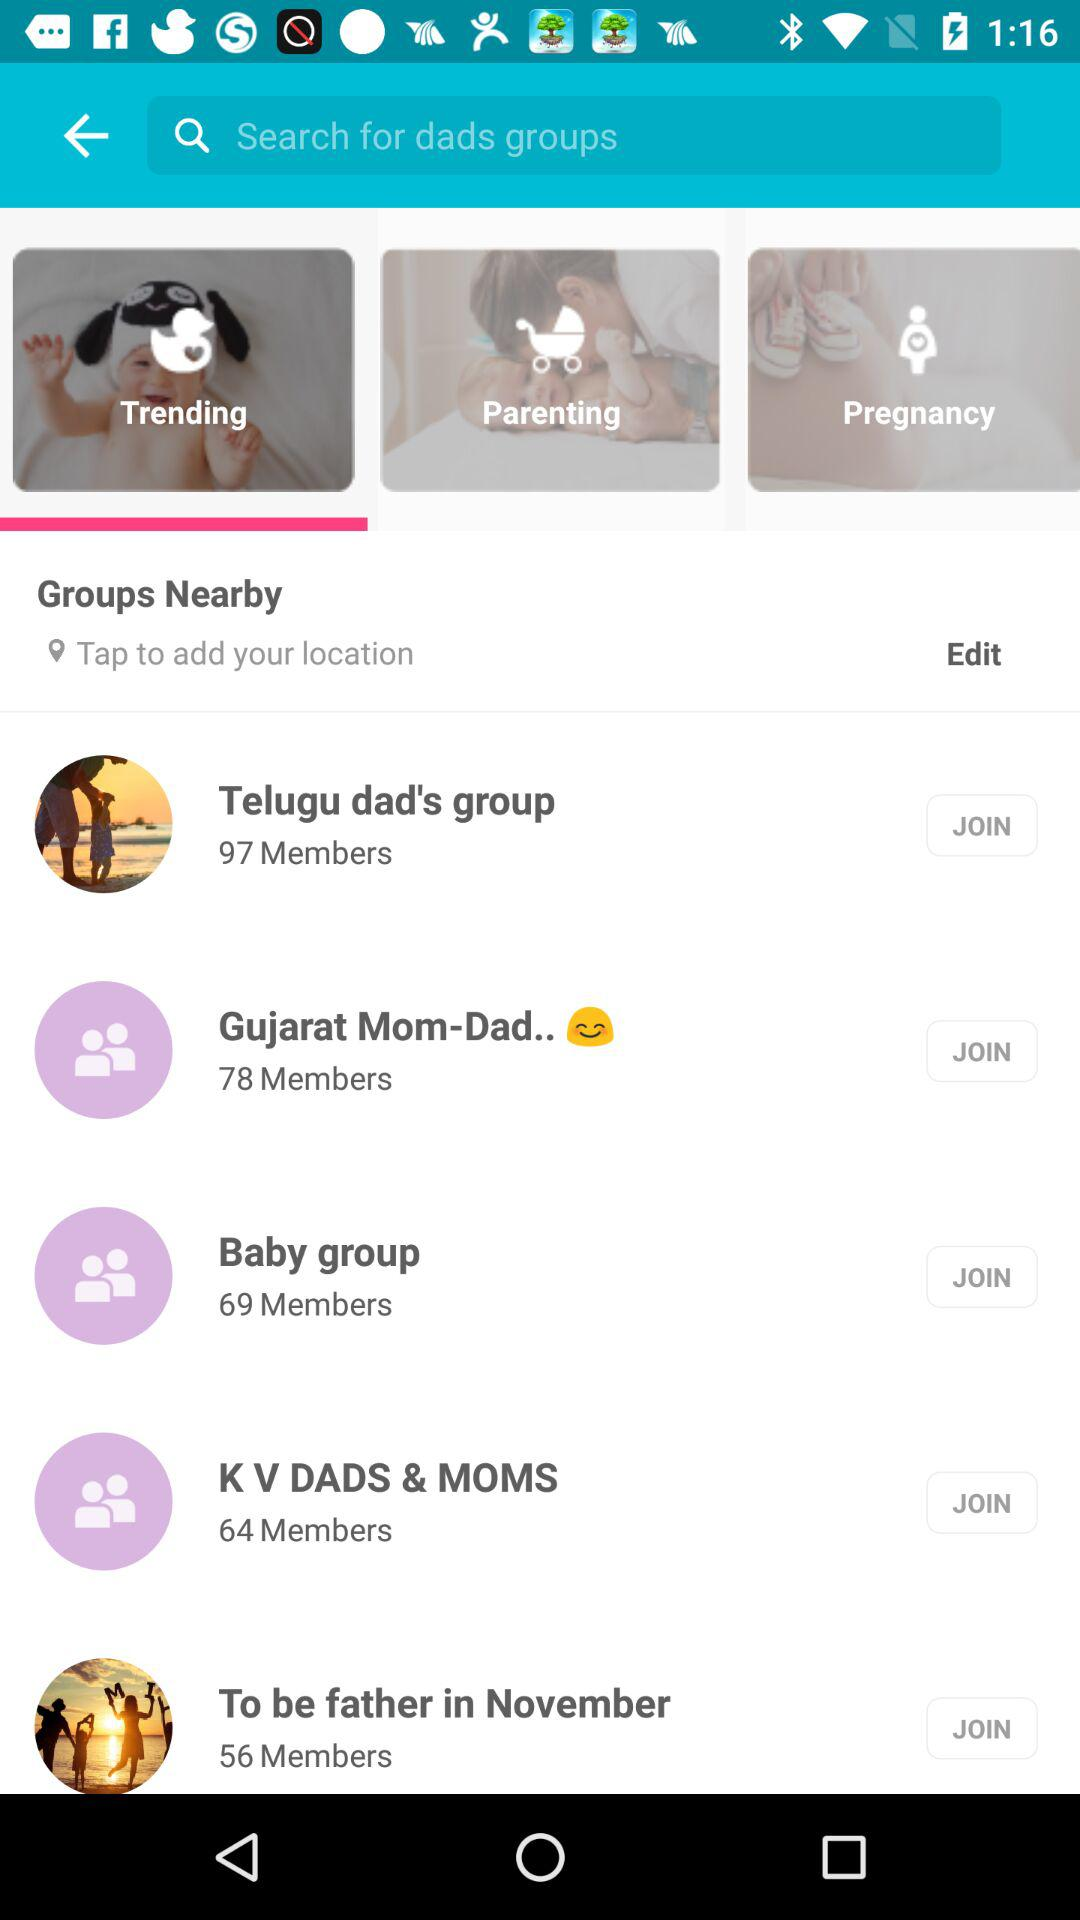How many more members does the Telugu dad's group have than the To be father in November group?
Answer the question using a single word or phrase. 41 